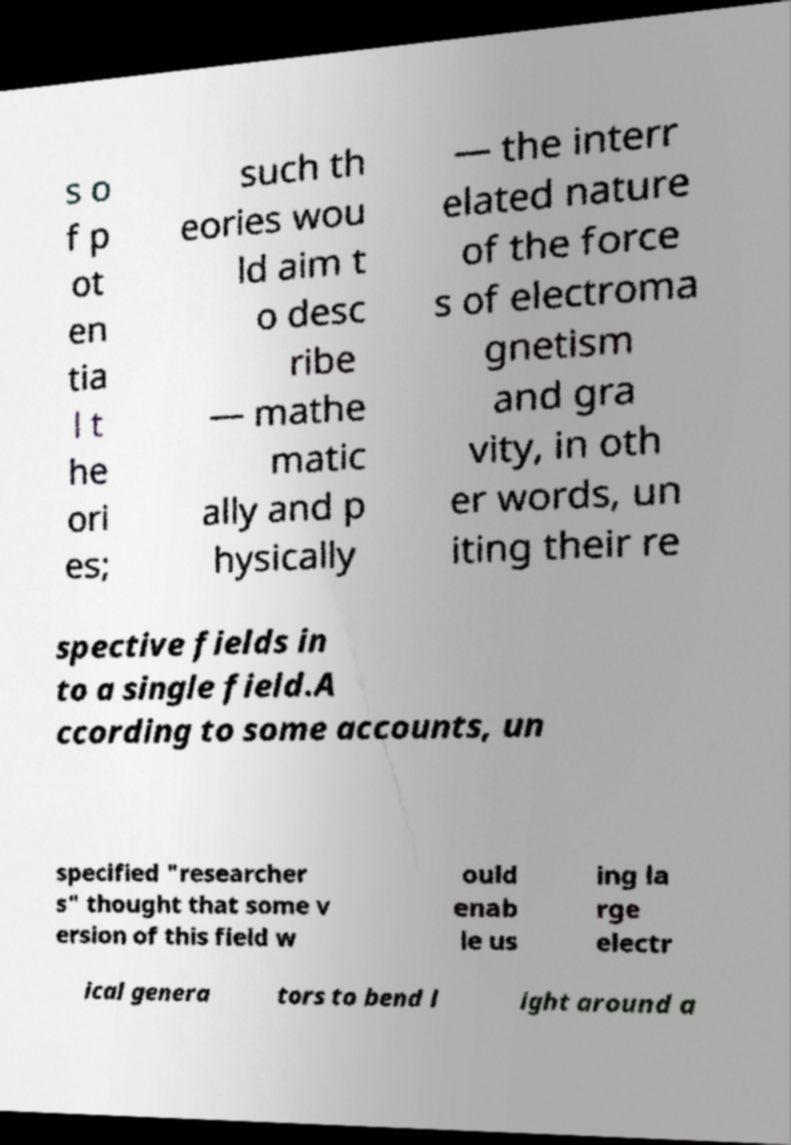Could you assist in decoding the text presented in this image and type it out clearly? s o f p ot en tia l t he ori es; such th eories wou ld aim t o desc ribe — mathe matic ally and p hysically — the interr elated nature of the force s of electroma gnetism and gra vity, in oth er words, un iting their re spective fields in to a single field.A ccording to some accounts, un specified "researcher s" thought that some v ersion of this field w ould enab le us ing la rge electr ical genera tors to bend l ight around a 